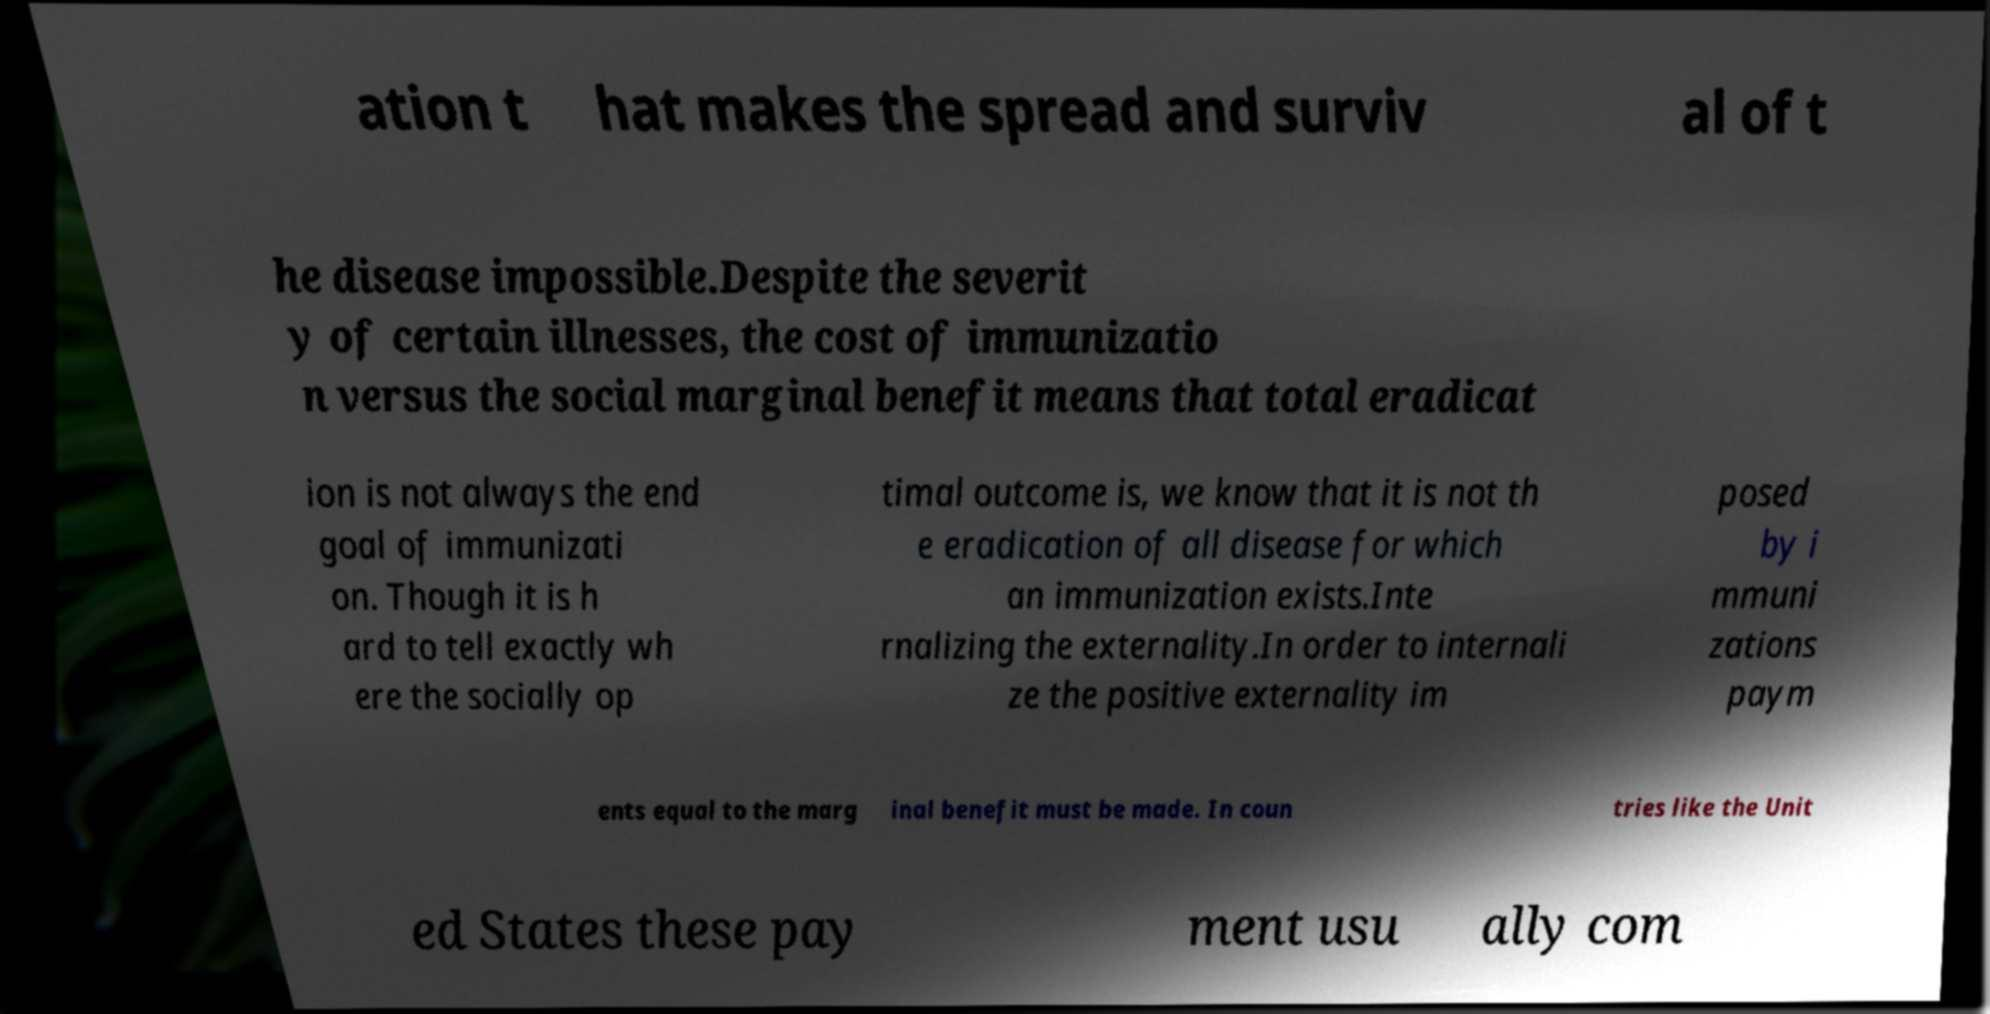For documentation purposes, I need the text within this image transcribed. Could you provide that? ation t hat makes the spread and surviv al of t he disease impossible.Despite the severit y of certain illnesses, the cost of immunizatio n versus the social marginal benefit means that total eradicat ion is not always the end goal of immunizati on. Though it is h ard to tell exactly wh ere the socially op timal outcome is, we know that it is not th e eradication of all disease for which an immunization exists.Inte rnalizing the externality.In order to internali ze the positive externality im posed by i mmuni zations paym ents equal to the marg inal benefit must be made. In coun tries like the Unit ed States these pay ment usu ally com 